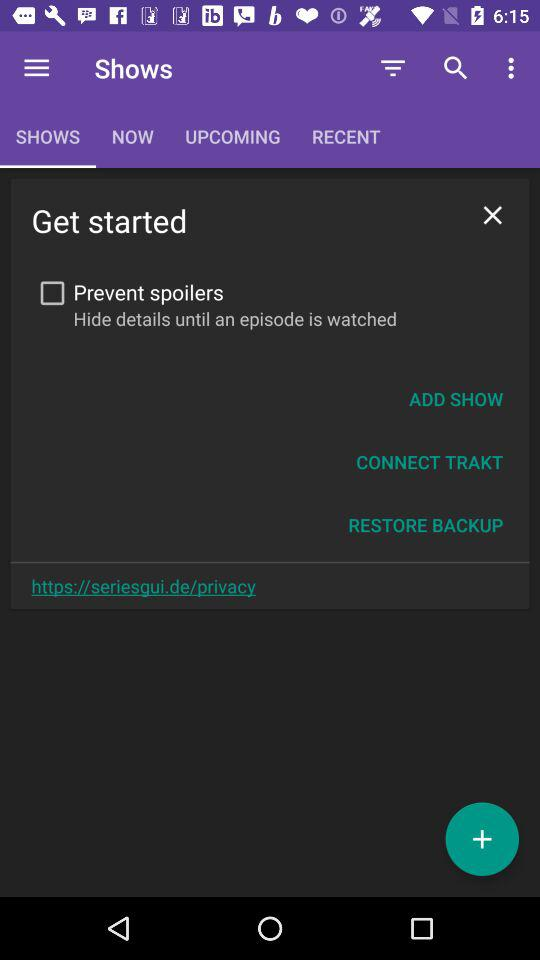What website can I visit for privacy? The website that you can visit for privacy is https://seriesqui.de/privacy. 